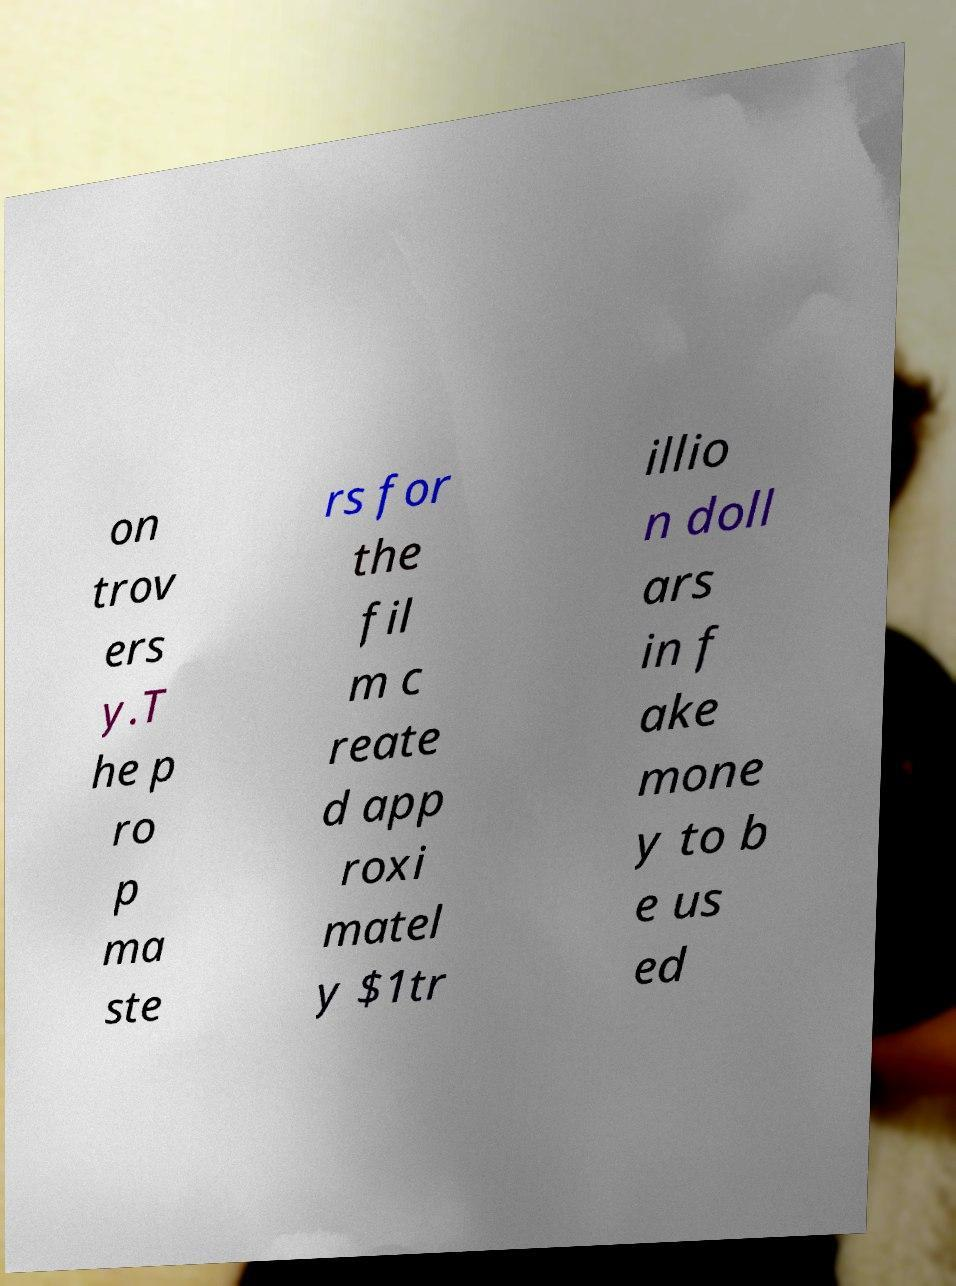There's text embedded in this image that I need extracted. Can you transcribe it verbatim? on trov ers y.T he p ro p ma ste rs for the fil m c reate d app roxi matel y $1tr illio n doll ars in f ake mone y to b e us ed 